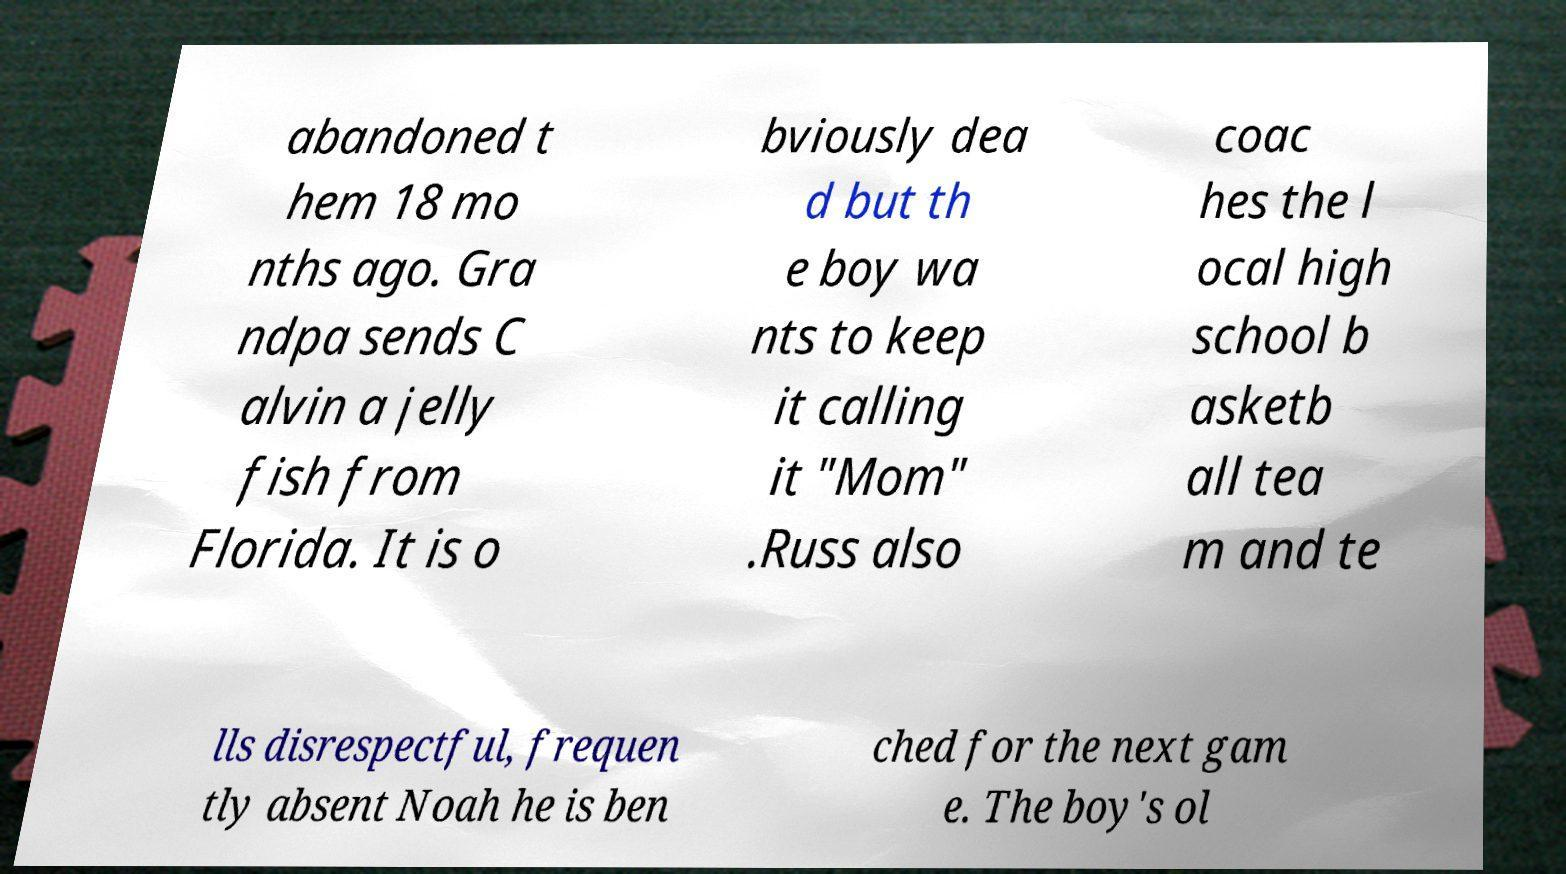Could you assist in decoding the text presented in this image and type it out clearly? abandoned t hem 18 mo nths ago. Gra ndpa sends C alvin a jelly fish from Florida. It is o bviously dea d but th e boy wa nts to keep it calling it "Mom" .Russ also coac hes the l ocal high school b asketb all tea m and te lls disrespectful, frequen tly absent Noah he is ben ched for the next gam e. The boy's ol 